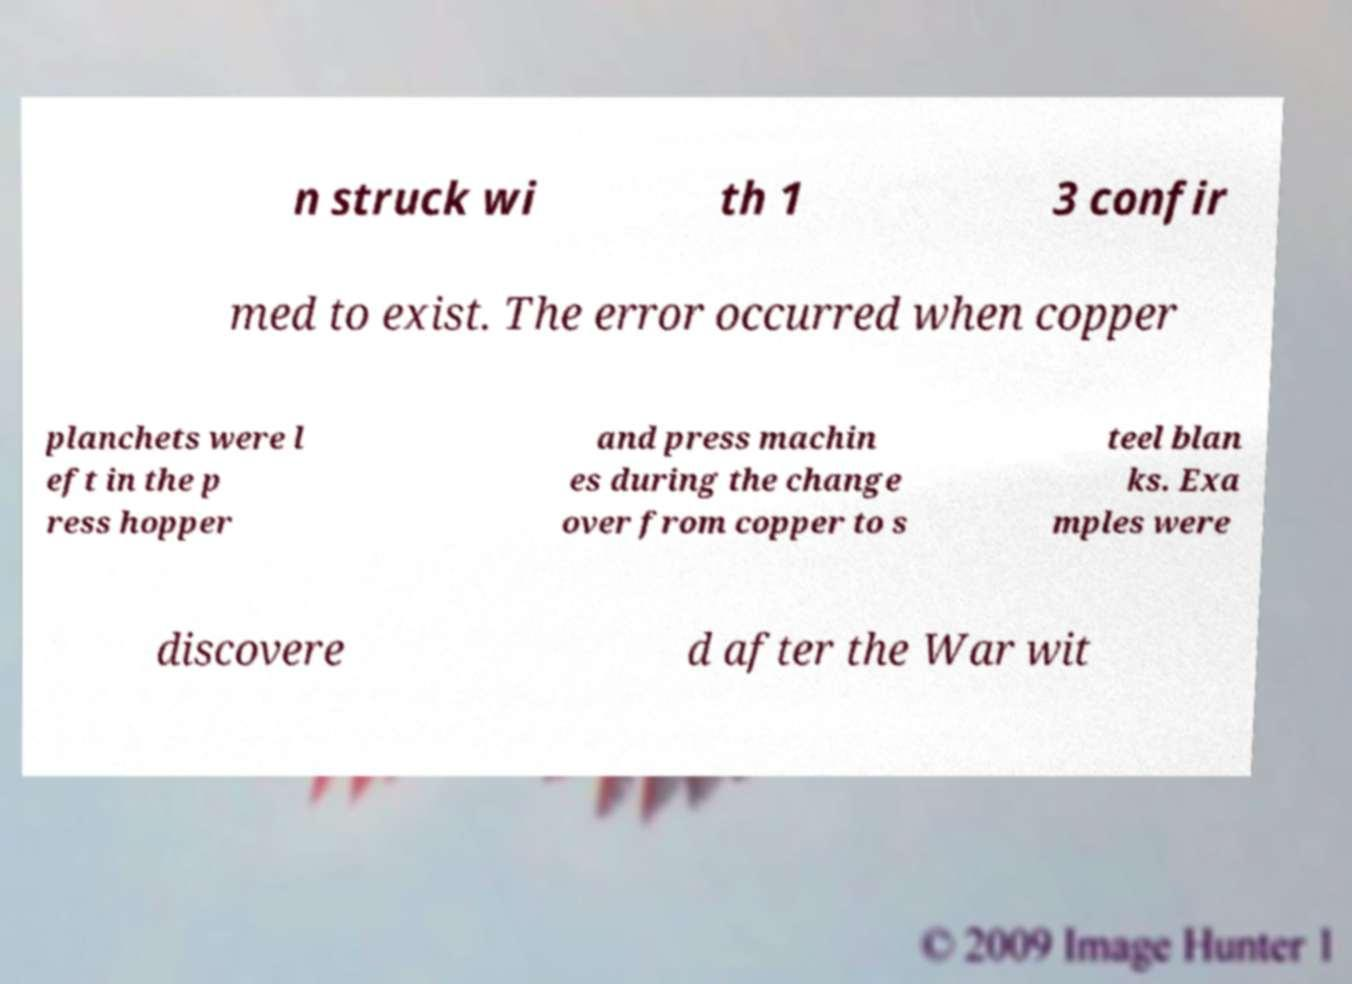What messages or text are displayed in this image? I need them in a readable, typed format. n struck wi th 1 3 confir med to exist. The error occurred when copper planchets were l eft in the p ress hopper and press machin es during the change over from copper to s teel blan ks. Exa mples were discovere d after the War wit 